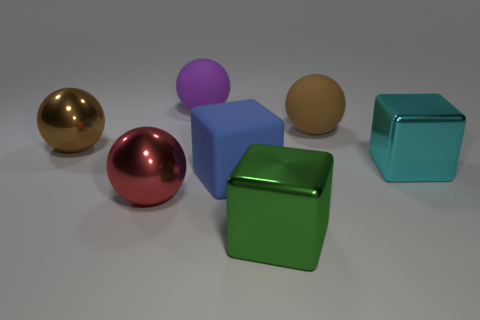What number of cyan cubes have the same size as the red sphere?
Your answer should be very brief. 1. How many tiny things are purple balls or cyan shiny things?
Your answer should be compact. 0. Are any large shiny blocks visible?
Keep it short and to the point. Yes. Are there more large brown spheres behind the red object than cyan metal things that are on the left side of the large cyan object?
Give a very brief answer. Yes. The large metallic object behind the large block behind the matte cube is what color?
Ensure brevity in your answer.  Brown. There is a thing on the right side of the rubber sphere to the right of the large green object that is right of the blue thing; what size is it?
Provide a short and direct response. Large. What shape is the purple matte object?
Ensure brevity in your answer.  Sphere. There is a matte object that is in front of the brown rubber object; what number of large green metallic blocks are behind it?
Your response must be concise. 0. How many other objects are there of the same material as the red sphere?
Give a very brief answer. 3. Do the large purple sphere behind the cyan shiny cube and the ball that is on the left side of the red shiny thing have the same material?
Give a very brief answer. No. 